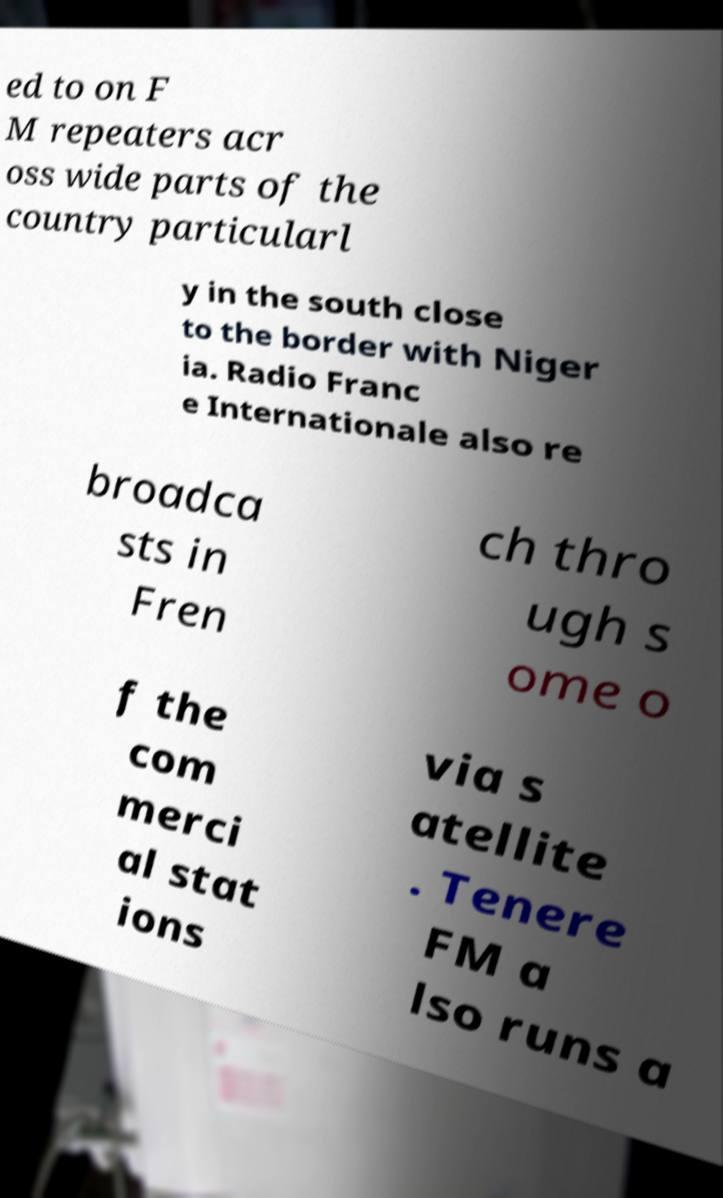Can you accurately transcribe the text from the provided image for me? ed to on F M repeaters acr oss wide parts of the country particularl y in the south close to the border with Niger ia. Radio Franc e Internationale also re broadca sts in Fren ch thro ugh s ome o f the com merci al stat ions via s atellite . Tenere FM a lso runs a 